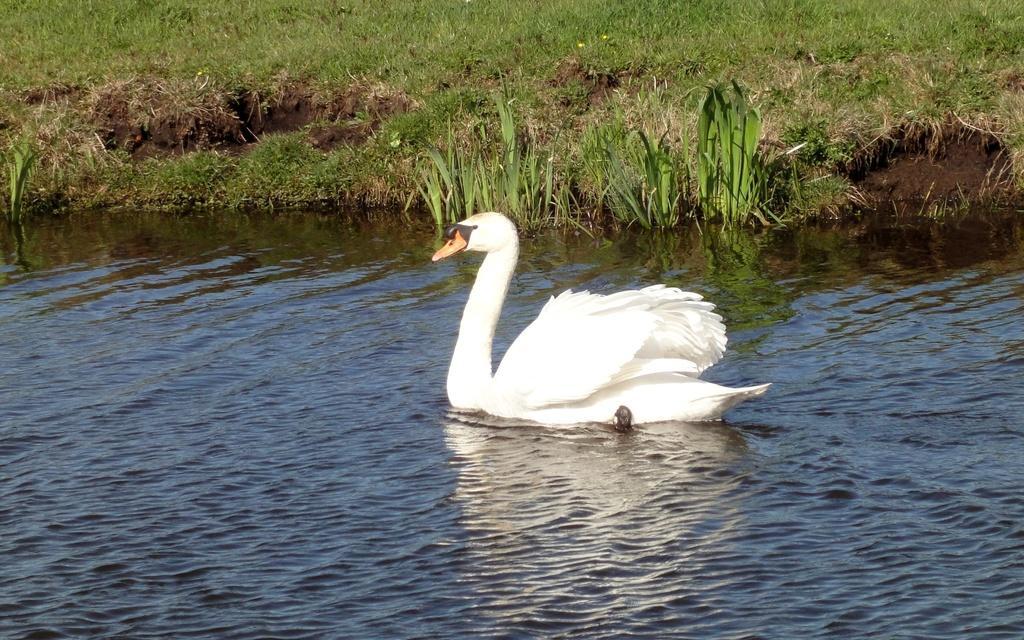How would you summarize this image in a sentence or two? In this image, I can see a swan in the water. This is the grass, which is green in color. 